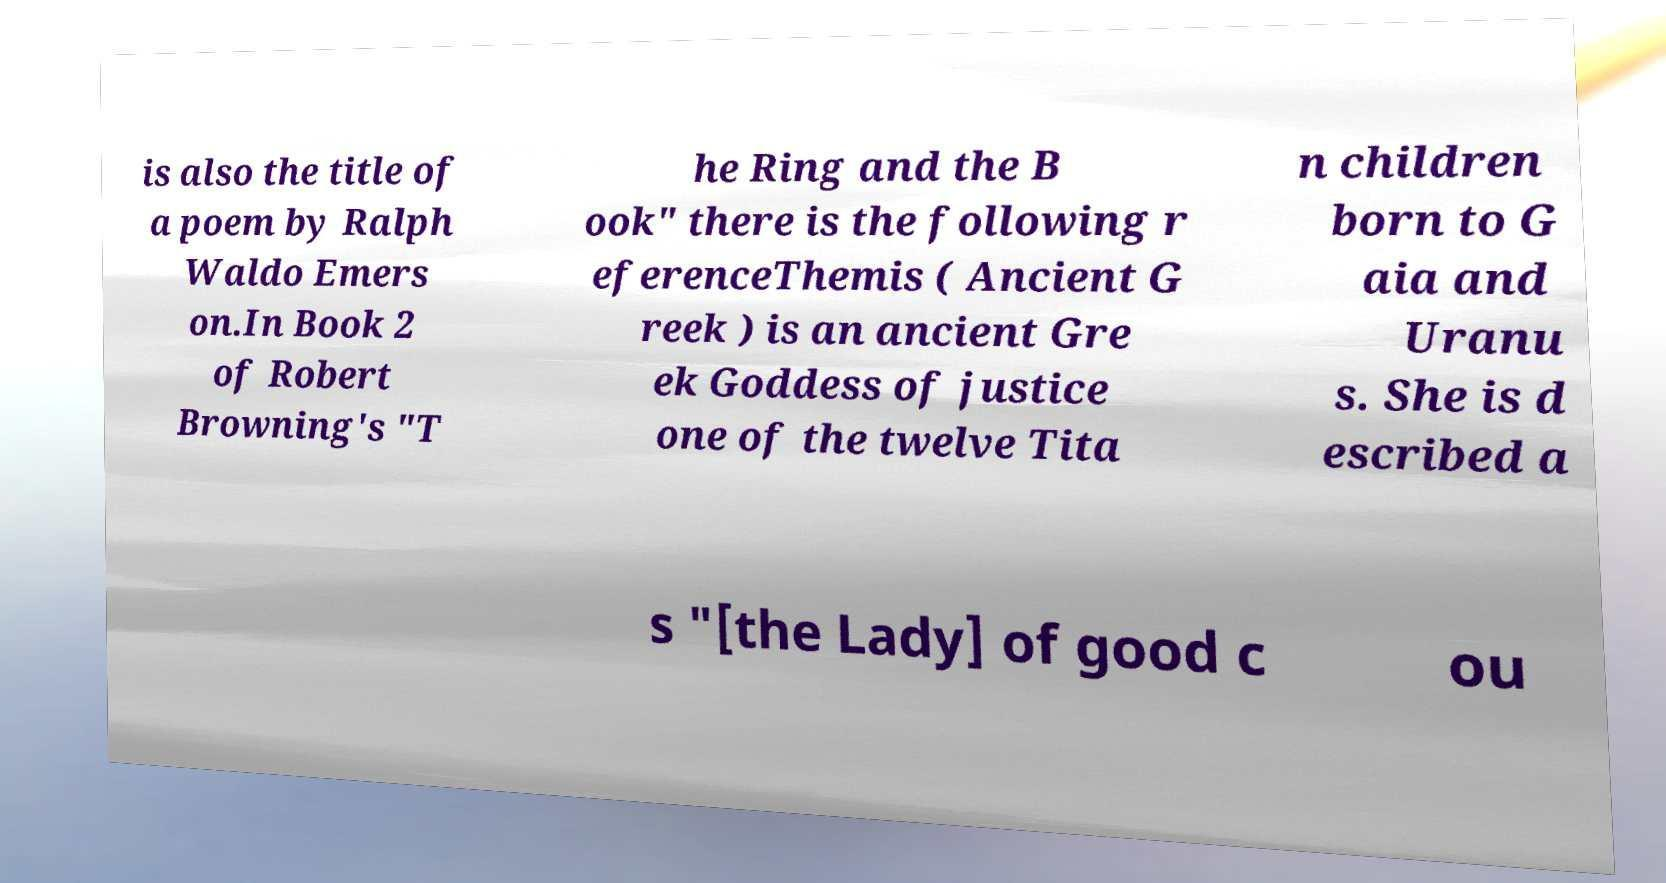Please read and relay the text visible in this image. What does it say? is also the title of a poem by Ralph Waldo Emers on.In Book 2 of Robert Browning's "T he Ring and the B ook" there is the following r eferenceThemis ( Ancient G reek ) is an ancient Gre ek Goddess of justice one of the twelve Tita n children born to G aia and Uranu s. She is d escribed a s "[the Lady] of good c ou 